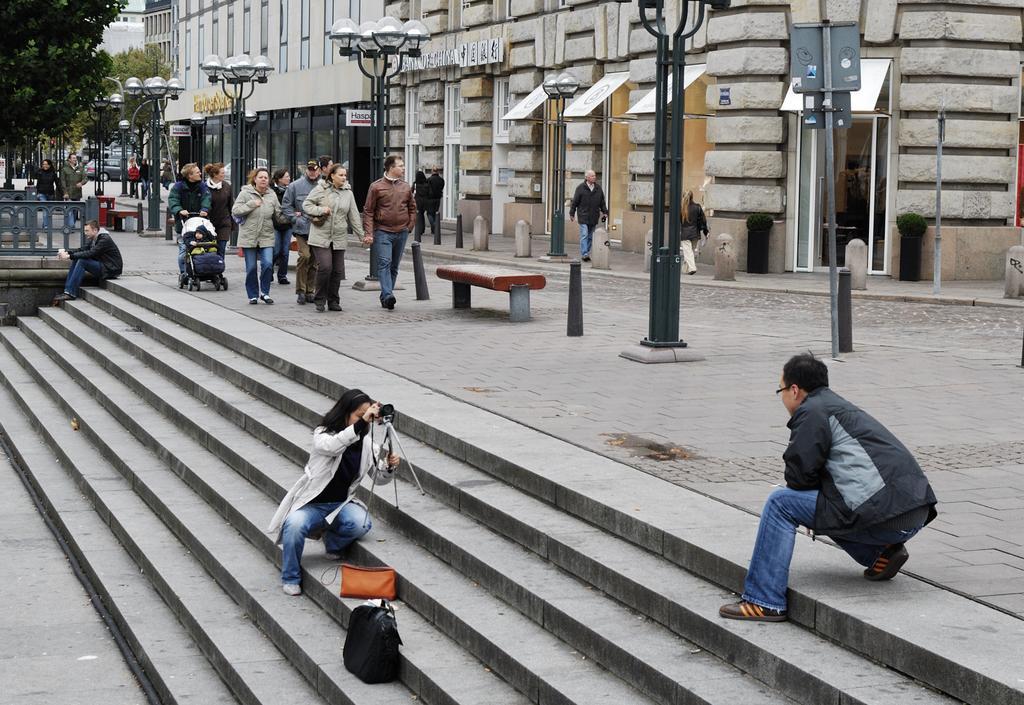In one or two sentences, can you explain what this image depicts? In this picture there is a man who is wearing jacket, jeans, spectacle and shoe. He is in squat position. On the bottom there is a woman who is wearing jacket, t-shirt, jeans and holding camera. She is in squat position. On the stairs we can see the purse and bag. On the left there is a man who is sitting near to the fencing, behind him we can see the group of persons walking on the street. Beside them we can see street lights, cones and bench. In the background we can see building, cars, road, trees and poles. On the top left corner there is a sky. 